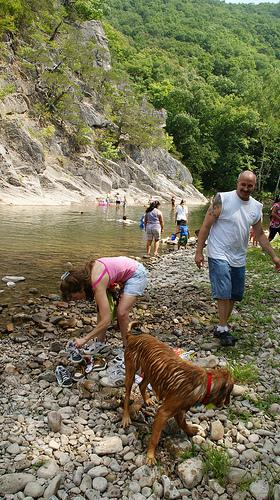Question: where was this photographed?
Choices:
A. Lake.
B. Lagoon.
C. Pond.
D. River.
Answer with the letter. Answer: D Question: what species appears closest to the camera?
Choices:
A. Dog.
B. Cat.
C. Horse.
D. Canine.
Answer with the letter. Answer: D Question: what is the dog standing on?
Choices:
A. Stones.
B. Marbles.
C. Rocks.
D. Granite.
Answer with the letter. Answer: A 